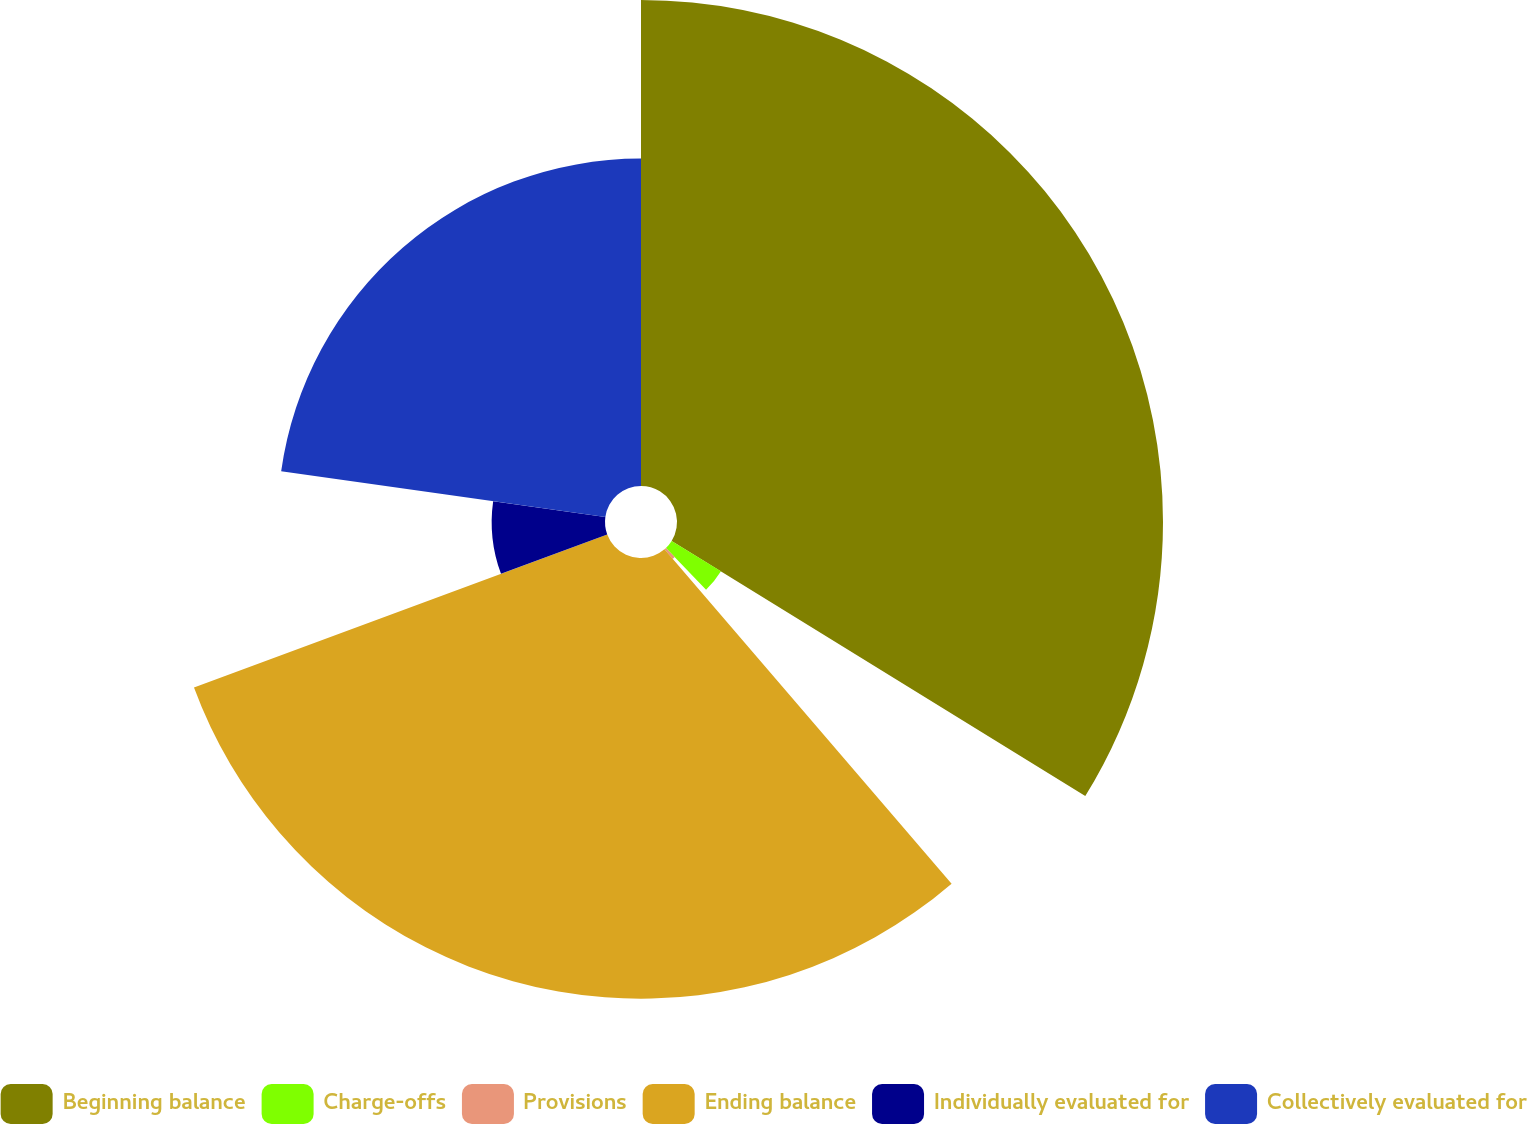Convert chart to OTSL. <chart><loc_0><loc_0><loc_500><loc_500><pie_chart><fcel>Beginning balance<fcel>Charge-offs<fcel>Provisions<fcel>Ending balance<fcel>Individually evaluated for<fcel>Collectively evaluated for<nl><fcel>33.8%<fcel>4.03%<fcel>0.88%<fcel>30.65%<fcel>7.88%<fcel>22.77%<nl></chart> 